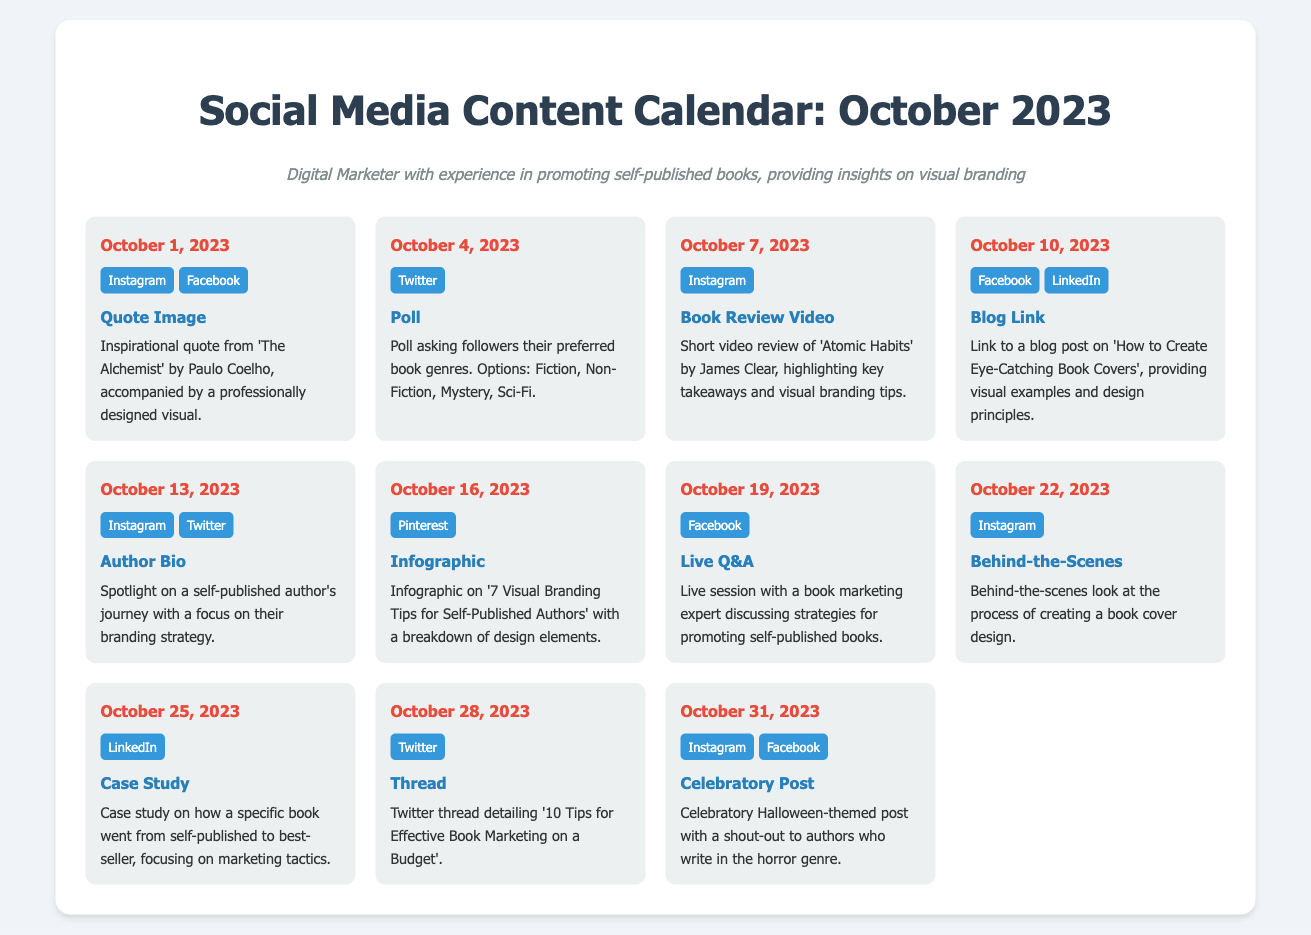What is the date of the first event? The first event is scheduled for October 1, 2023.
Answer: October 1, 2023 How many platforms are featured for the event on October 10? The event on October 10 has two platforms mentioned: Facebook and LinkedIn.
Answer: 2 What type of content is posted on October 16? On October 16, an infographic is shared outlining visual branding tips.
Answer: Infographic Which book is reviewed on October 7? The book reviewed on October 7 is 'Atomic Habits' by James Clear.
Answer: Atomic Habits What type of post is scheduled for October 22? The event on October 22 includes a behind-the-scenes post about book cover design.
Answer: Behind-the-Scenes Which platform is used for the case study post on October 25? The case study post on October 25 will be shared on LinkedIn.
Answer: LinkedIn What is the theme of the post on October 31? The theme of the post on October 31 is Halloween, celebrating authors in the horror genre.
Answer: Halloween How many events are there in total for October 2023? There are ten events planned for the month of October 2023.
Answer: 10 On what date is the live Q&A scheduled? The live Q&A is scheduled for October 19, 2023.
Answer: October 19, 2023 